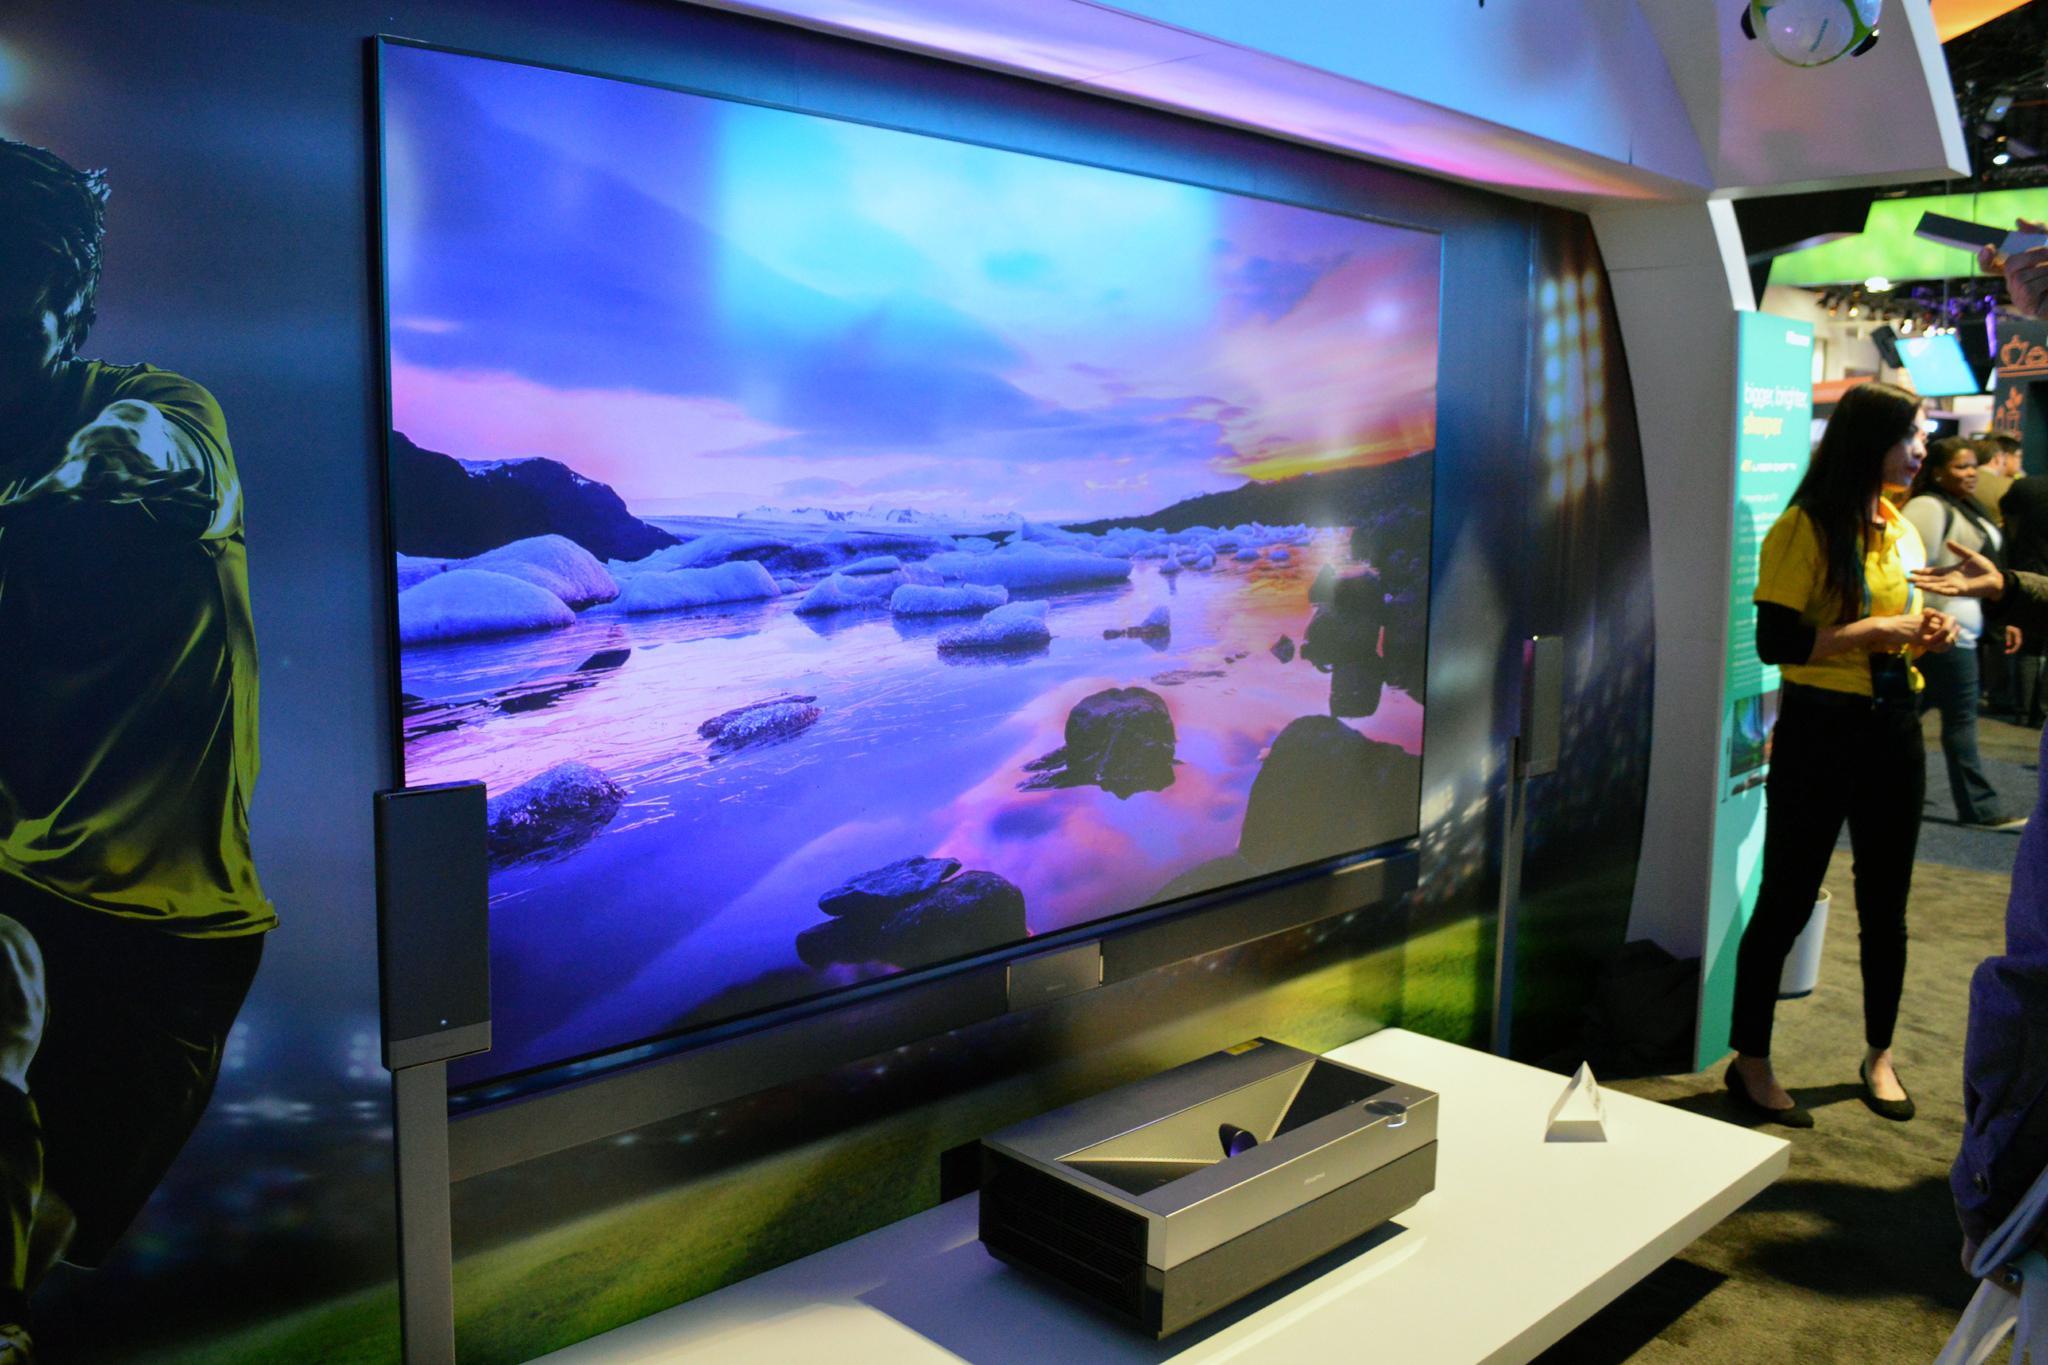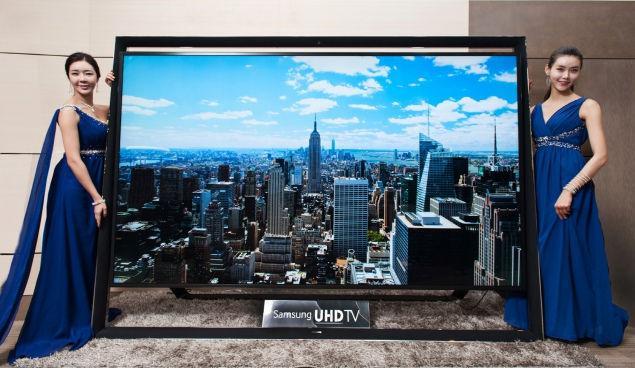The first image is the image on the left, the second image is the image on the right. Considering the images on both sides, is "One image shows an arch over a screen displaying a picture of red and blue berries around a shiny red rounded thing." valid? Answer yes or no. No. The first image is the image on the left, the second image is the image on the right. Evaluate the accuracy of this statement regarding the images: "The image in the right television display portrays a person.". Is it true? Answer yes or no. No. 